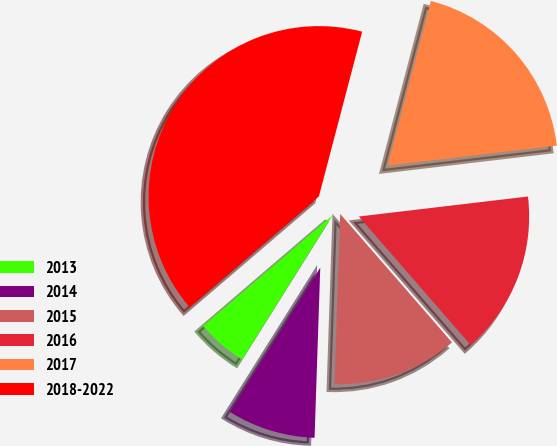Convert chart. <chart><loc_0><loc_0><loc_500><loc_500><pie_chart><fcel>2013<fcel>2014<fcel>2015<fcel>2016<fcel>2017<fcel>2018-2022<nl><fcel>4.82%<fcel>8.38%<fcel>11.93%<fcel>15.48%<fcel>19.04%<fcel>40.36%<nl></chart> 